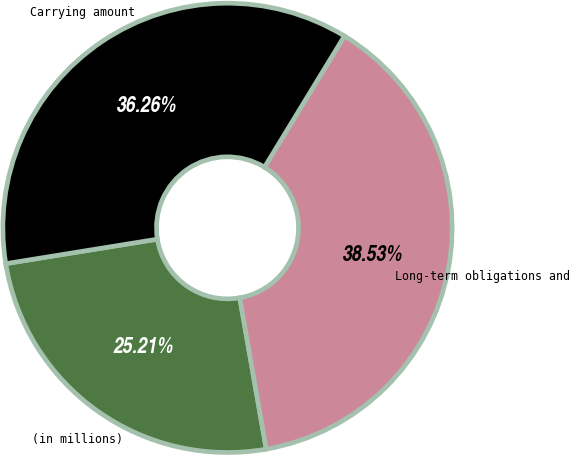Convert chart. <chart><loc_0><loc_0><loc_500><loc_500><pie_chart><fcel>(in millions)<fcel>Long-term obligations and<fcel>Carrying amount<nl><fcel>25.21%<fcel>38.53%<fcel>36.26%<nl></chart> 